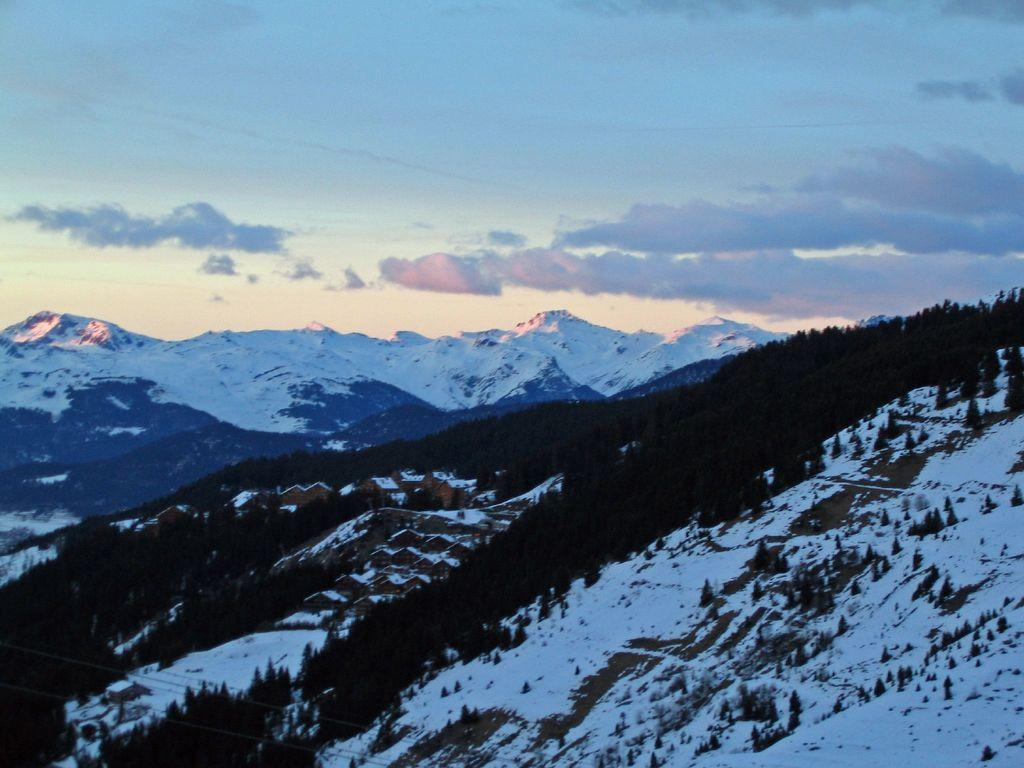What type of geographical feature is present in the image? There are mountains in the image. Are there any specific conditions affecting the appearance of the mountains? Some mountains are covered with snow. What can be seen in the background of the image? The sky is visible in the background of the image. Can you tell me how many bags of rice are visible in the image? There are no bags of rice present in the image; it features mountains and a sky. Is there a baby visible in the image? There is no baby present in the image; it features mountains and a sky. 